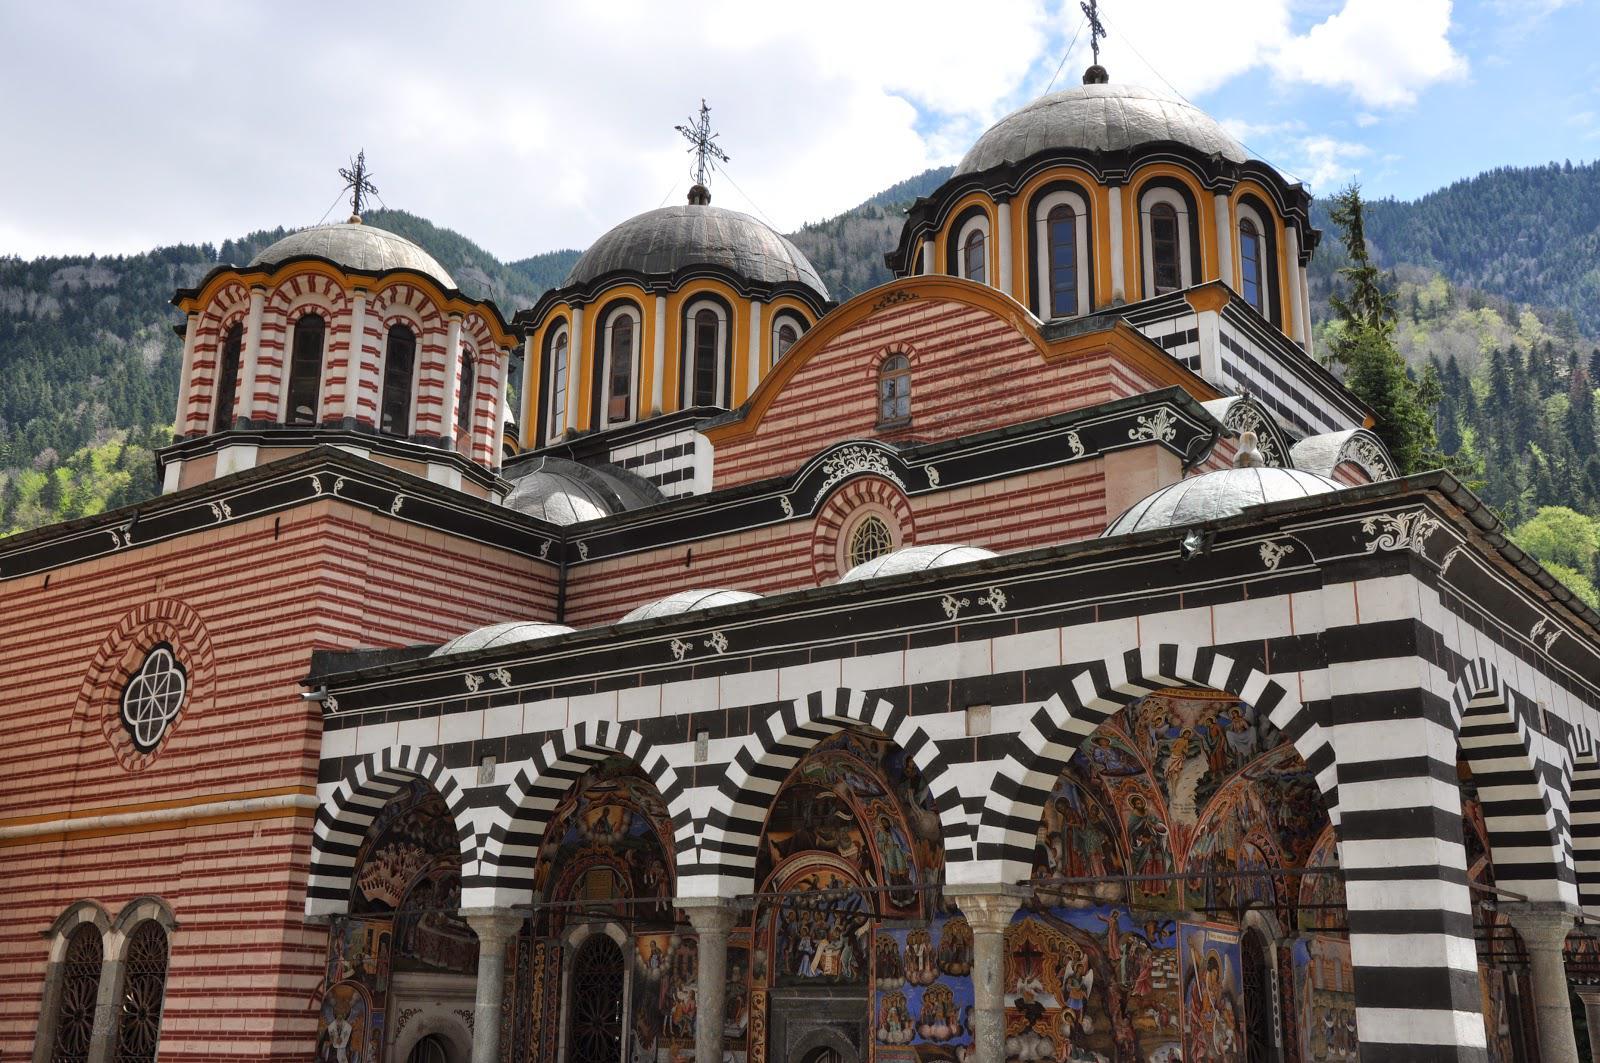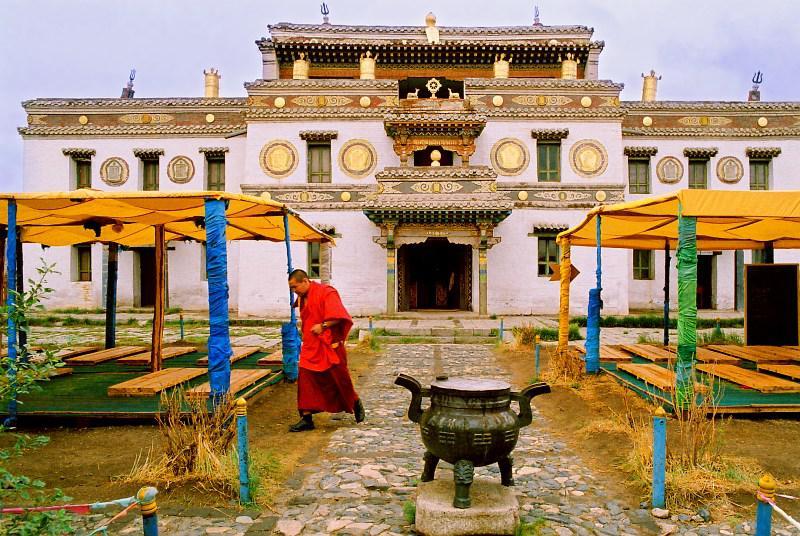The first image is the image on the left, the second image is the image on the right. Given the left and right images, does the statement "A stone path with a cauldron-type item leads to a grand entrance of a temple in one image." hold true? Answer yes or no. Yes. The first image is the image on the left, the second image is the image on the right. For the images displayed, is the sentence "At least one religious cross can be seen in one image." factually correct? Answer yes or no. Yes. 